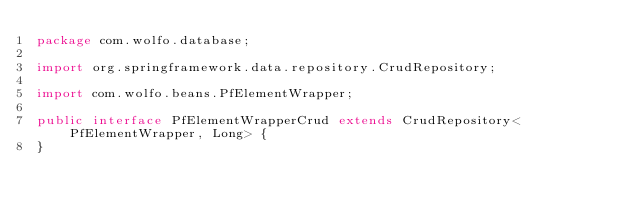<code> <loc_0><loc_0><loc_500><loc_500><_Java_>package com.wolfo.database;

import org.springframework.data.repository.CrudRepository;

import com.wolfo.beans.PfElementWrapper;

public interface PfElementWrapperCrud extends CrudRepository<PfElementWrapper, Long> {
}
</code> 